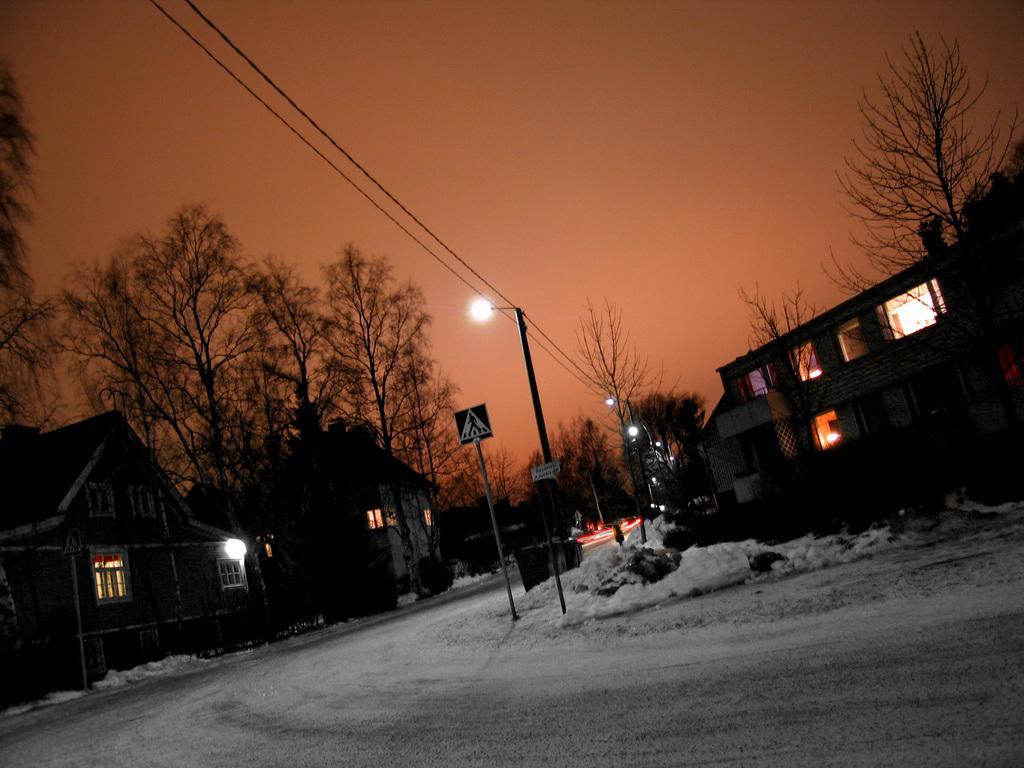Describe this image in one or two sentences. In this image in the center there are poles. On the left side there are buildings, trees. In the background there are trees, poles. On the right side there are trees and buildings and on the the floor there is snow. 